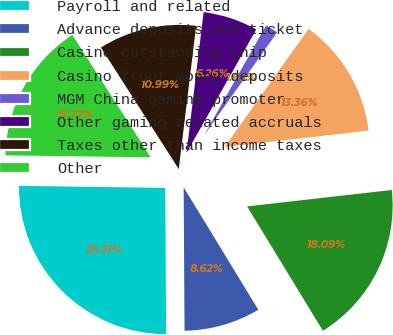Convert chart. <chart><loc_0><loc_0><loc_500><loc_500><pie_chart><fcel>Payroll and related<fcel>Advance deposits and ticket<fcel>Casino outstanding chip<fcel>Casino front money deposits<fcel>MGM China gaming promoter<fcel>Other gaming related accruals<fcel>Taxes other than income taxes<fcel>Other<nl><fcel>25.31%<fcel>8.62%<fcel>18.09%<fcel>13.36%<fcel>1.65%<fcel>6.26%<fcel>10.99%<fcel>15.72%<nl></chart> 